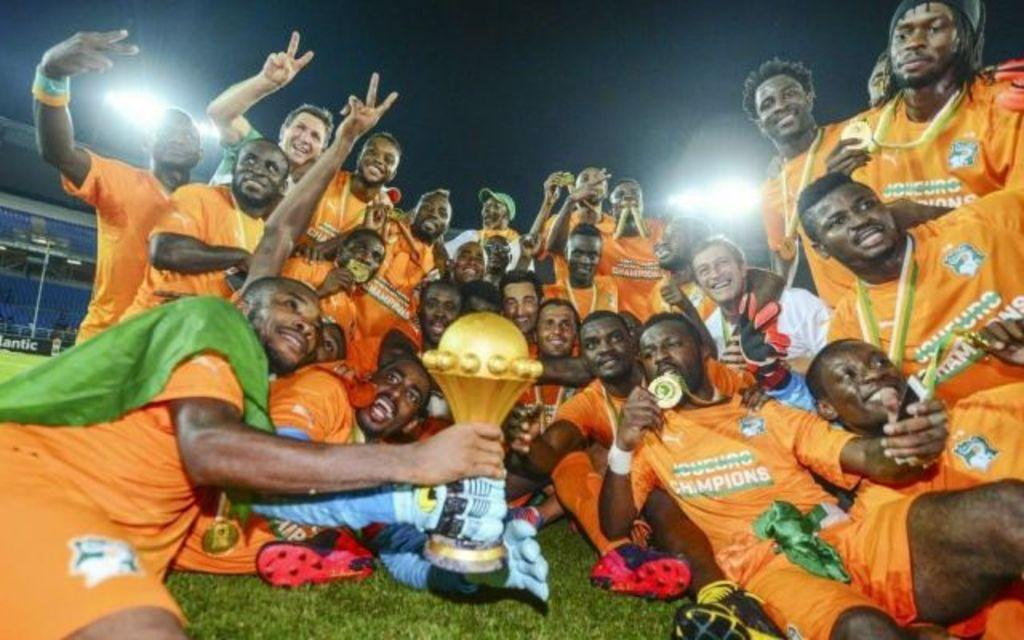What type of location is depicted in the image? The image is of a stadium. Can you describe the people in the image? There are groups of people in the image, and they are smiling. What are two persons holding in the image? Two persons are holding a trophy in the image. What type of lighting is present in the image? There are lights in the image. What type of seating is available in the image? There are chairs in the image. What is the background of the image? The sky is visible in the background of the image. What type of argument is taking place between the two persons holding the trophy in the image? There is no argument taking place in the image; the two persons are holding a trophy and smiling. Can you describe the type of skate that is visible in the image? There is no skate present in the image. 